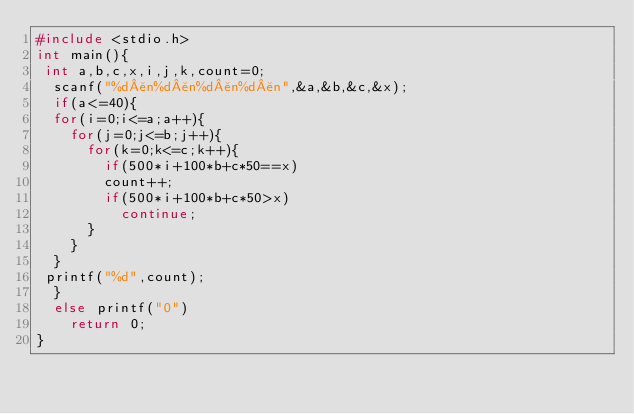Convert code to text. <code><loc_0><loc_0><loc_500><loc_500><_C_>#include <stdio.h>
int main(){
 int a,b,c,x,i,j,k,count=0;
  scanf("%d¥n%d¥n%d¥n%d¥n",&a,&b,&c,&x);
  if(a<=40){
  for(i=0;i<=a;a++){
    for(j=0;j<=b;j++){
      for(k=0;k<=c;k++){
        if(500*i+100*b+c*50==x)
        count++;
        if(500*i+100*b+c*50>x)
          continue;
      }
    }
  }
 printf("%d",count);
  }
  else printf("0")
    return 0;
}
</code> 